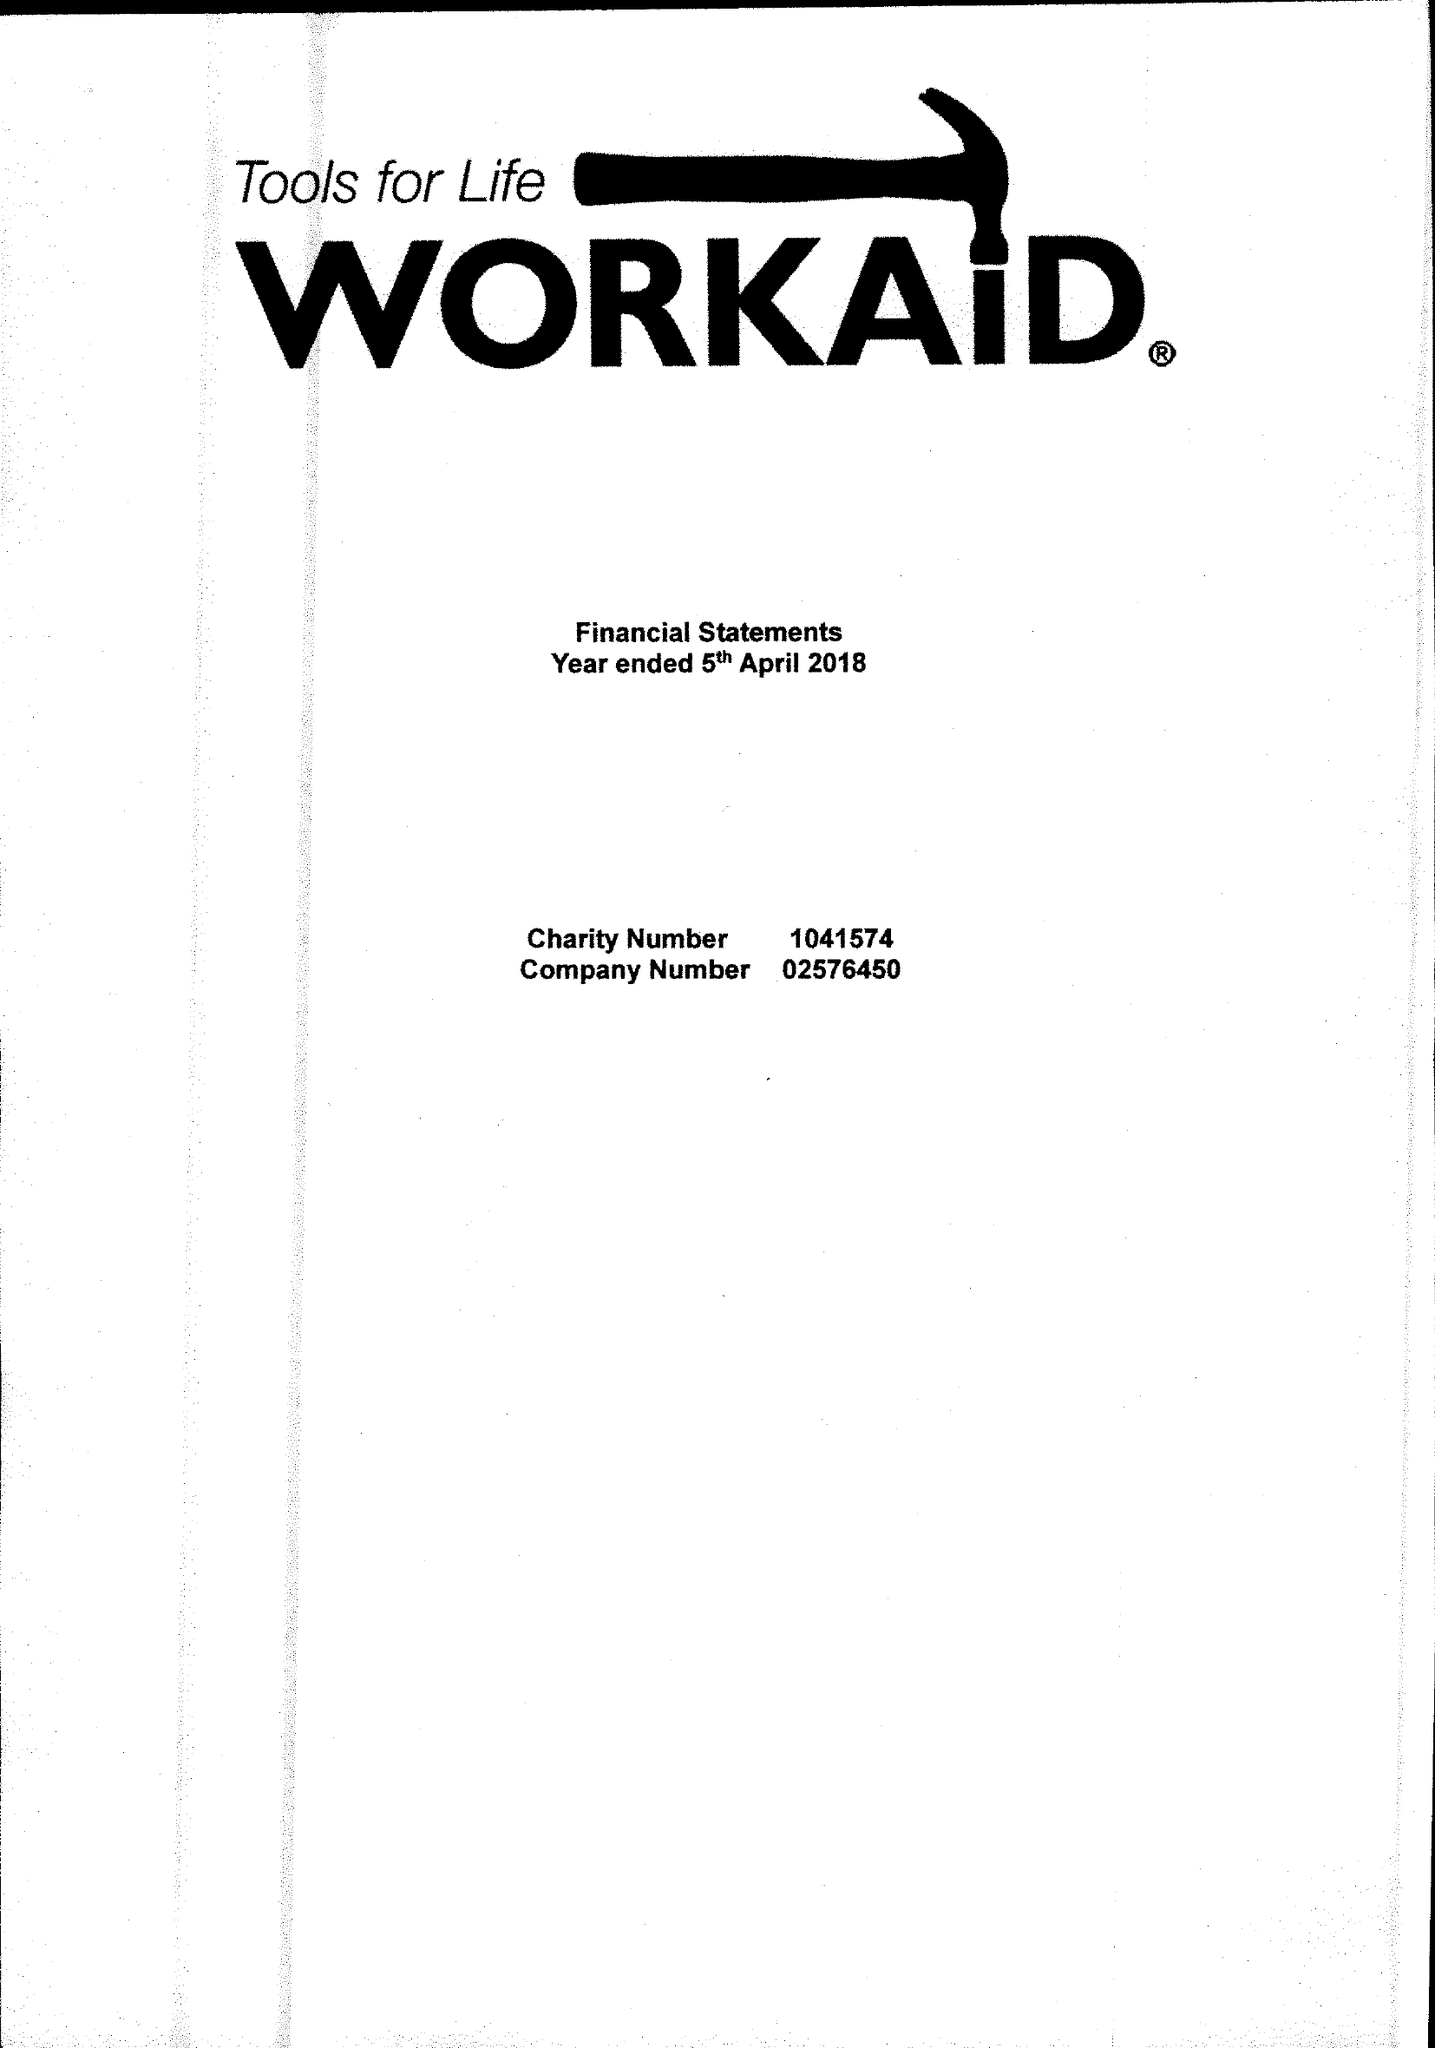What is the value for the charity_number?
Answer the question using a single word or phrase. 1041574 